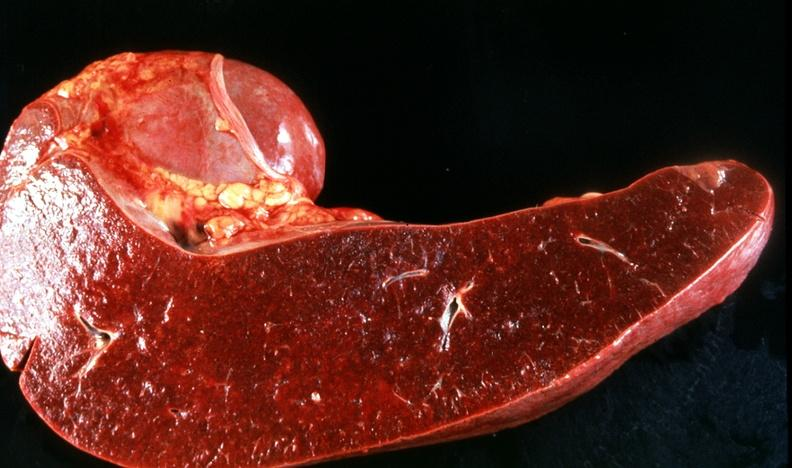what does this image show?
Answer the question using a single word or phrase. Spleen 